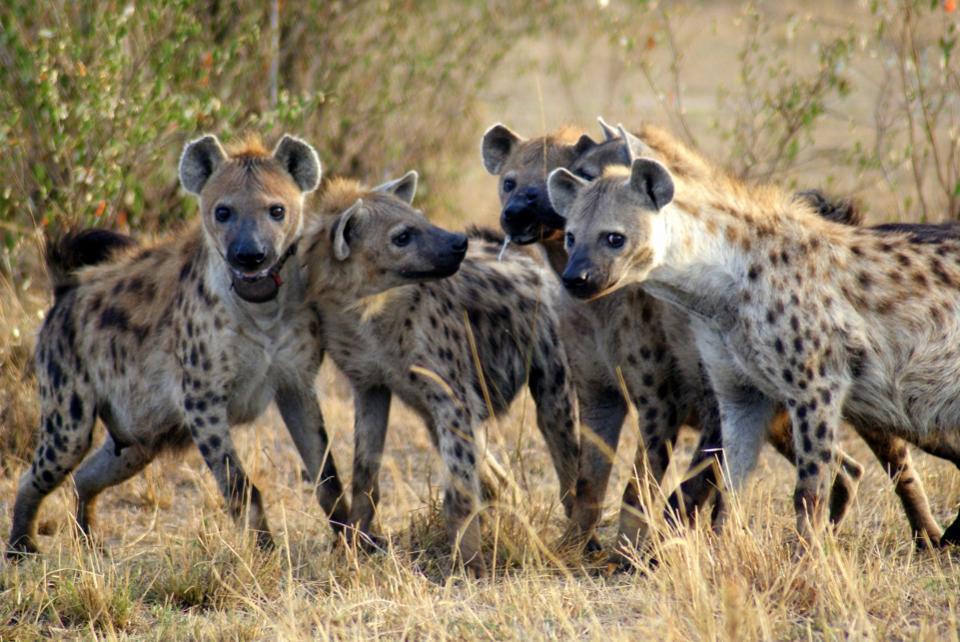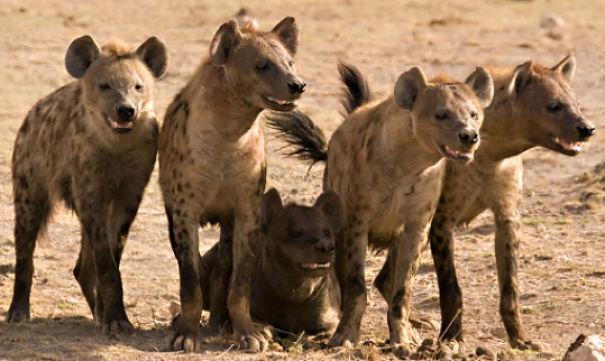The first image is the image on the left, the second image is the image on the right. Examine the images to the left and right. Is the description "Right image shows a close grouping of no more than five hyenas." accurate? Answer yes or no. Yes. The first image is the image on the left, the second image is the image on the right. Considering the images on both sides, is "One image contains at least one lion." valid? Answer yes or no. No. The first image is the image on the left, the second image is the image on the right. Evaluate the accuracy of this statement regarding the images: "A lion is with a group of hyenas in at least one of the images.". Is it true? Answer yes or no. No. 